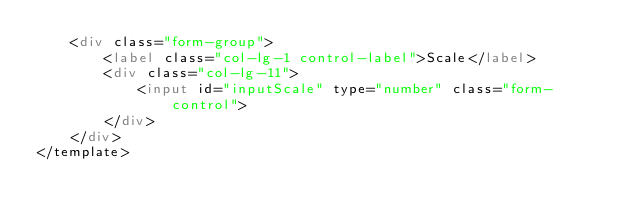<code> <loc_0><loc_0><loc_500><loc_500><_HTML_>    <div class="form-group">
        <label class="col-lg-1 control-label">Scale</label>
        <div class="col-lg-11">
            <input id="inputScale" type="number" class="form-control">
        </div>
    </div>
</template></code> 